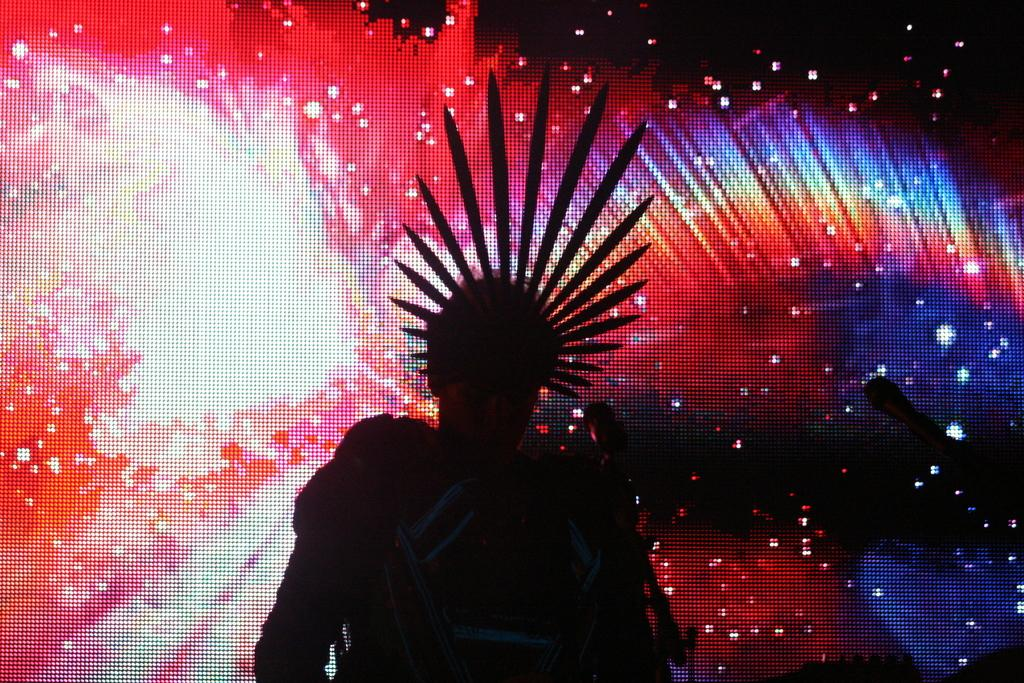What is present in the image? There is a person in the image. What can be observed on the person's head? The person has something on their head. What is visible in the background of the image? There is a screen in the background of the image. What is displayed on the screen? There are lights displayed on the screen. How does the person in the image breathe underwater? There is no indication in the image that the person is underwater or needs to breathe underwater. 